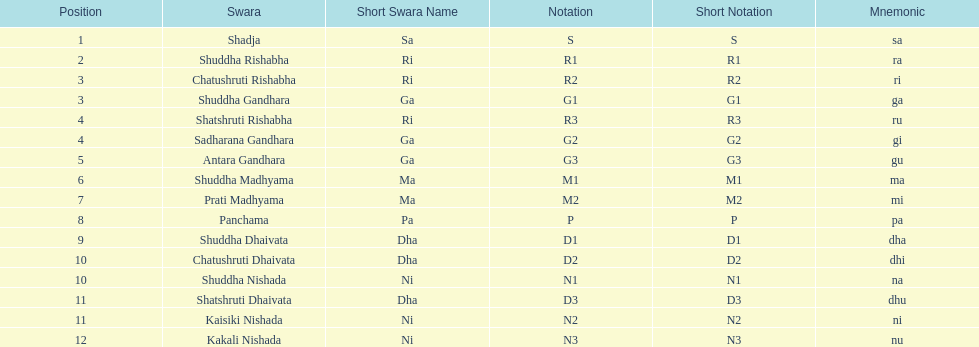Parse the table in full. {'header': ['Position', 'Swara', 'Short Swara Name', 'Notation', 'Short Notation', 'Mnemonic'], 'rows': [['1', 'Shadja', 'Sa', 'S', 'S', 'sa'], ['2', 'Shuddha Rishabha', 'Ri', 'R1', 'R1', 'ra'], ['3', 'Chatushruti Rishabha', 'Ri', 'R2', 'R2', 'ri'], ['3', 'Shuddha Gandhara', 'Ga', 'G1', 'G1', 'ga'], ['4', 'Shatshruti Rishabha', 'Ri', 'R3', 'R3', 'ru'], ['4', 'Sadharana Gandhara', 'Ga', 'G2', 'G2', 'gi'], ['5', 'Antara Gandhara', 'Ga', 'G3', 'G3', 'gu'], ['6', 'Shuddha Madhyama', 'Ma', 'M1', 'M1', 'ma'], ['7', 'Prati Madhyama', 'Ma', 'M2', 'M2', 'mi'], ['8', 'Panchama', 'Pa', 'P', 'P', 'pa'], ['9', 'Shuddha Dhaivata', 'Dha', 'D1', 'D1', 'dha'], ['10', 'Chatushruti Dhaivata', 'Dha', 'D2', 'D2', 'dhi'], ['10', 'Shuddha Nishada', 'Ni', 'N1', 'N1', 'na'], ['11', 'Shatshruti Dhaivata', 'Dha', 'D3', 'D3', 'dhu'], ['11', 'Kaisiki Nishada', 'Ni', 'N2', 'N2', 'ni'], ['12', 'Kakali Nishada', 'Ni', 'N3', 'N3', 'nu']]} Find the 9th position swara. what is its short name? Dha. 